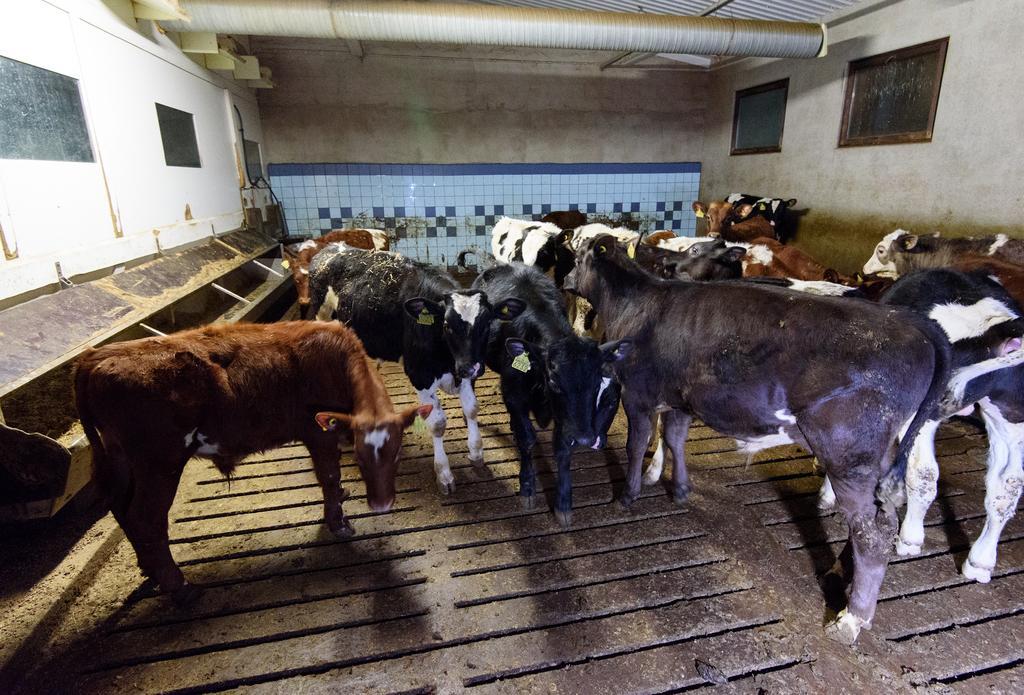Can you describe this image briefly? In this image, I can see a herd of cows. I think these are the windows. This looks like a wall. At the top of the image, I think this is a pipe. 